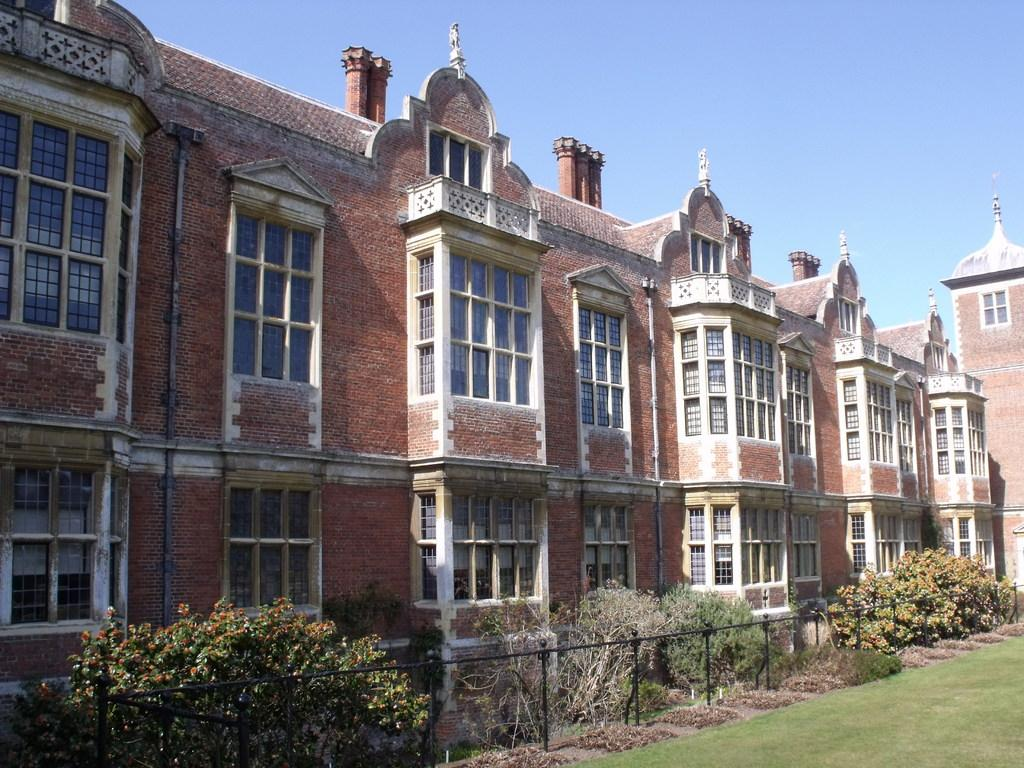What type of structures can be seen in the image? There are buildings in the image. What natural elements are present near the fencing in the image? There are trees near fencing in the image. What type of ground cover is visible in the image? There is grass visible in the image. What type of rose is your mom holding in the image? There is no person, including a mom, or rose present in the image. 